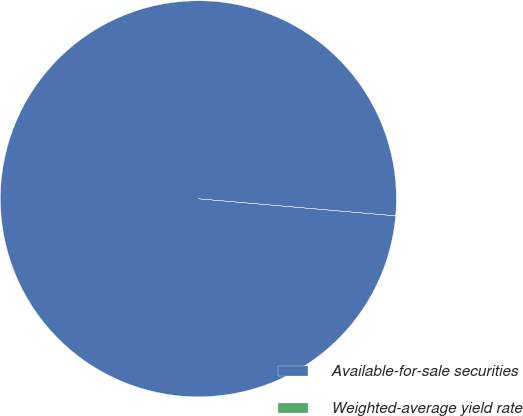Convert chart to OTSL. <chart><loc_0><loc_0><loc_500><loc_500><pie_chart><fcel>Available-for-sale securities<fcel>Weighted-average yield rate<nl><fcel>100.0%<fcel>0.0%<nl></chart> 